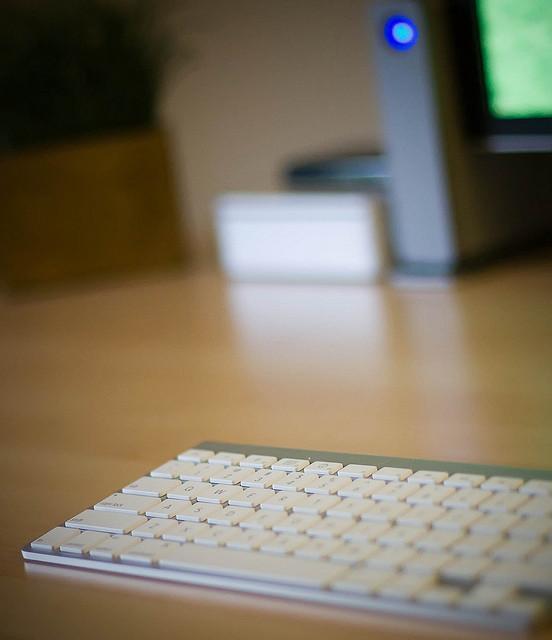How many buses are there?
Give a very brief answer. 0. 